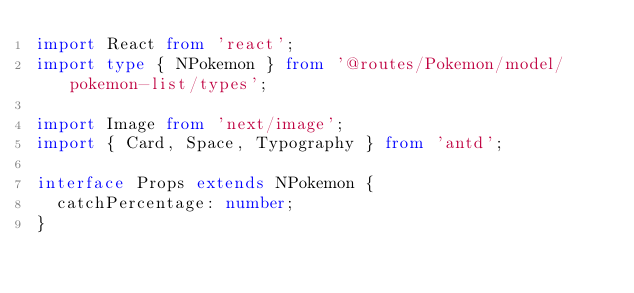<code> <loc_0><loc_0><loc_500><loc_500><_TypeScript_>import React from 'react';
import type { NPokemon } from '@routes/Pokemon/model/pokemon-list/types';

import Image from 'next/image';
import { Card, Space, Typography } from 'antd';

interface Props extends NPokemon {
  catchPercentage: number;
}
</code> 